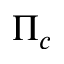<formula> <loc_0><loc_0><loc_500><loc_500>\Pi _ { c }</formula> 